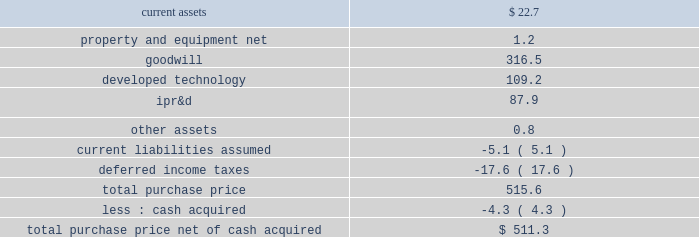Edwards lifesciences corporation notes to consolidated financial statements ( continued ) 7 .
Acquisitions ( continued ) transaction closed on january 23 , 2017 , and the consideration paid included the issuance of approximately 2.8 million shares of the company 2019s common stock ( fair value of $ 266.5 million ) and cash of $ 86.2 million .
The company recognized in 201ccontingent consideration liabilities 201d a $ 162.9 million liability for the estimated fair value of the contingent milestone payments .
The fair value of the contingent milestone payments will be remeasured each quarter , with changes in the fair value recognized within operating expenses on the consolidated statements of operations .
For further information on the fair value of the contingent milestone payments , see note 10 .
In connection with the acquisition , the company placed $ 27.6 million of the purchase price into escrow to satisfy any claims for indemnification made in accordance with the merger agreement .
Any funds remaining 15 months after the acquisition date will be disbursed to valtech 2019s former shareholders .
Acquisition-related costs of $ 0.6 million and $ 4.1 million were recorded in 201cselling , general , and administrative expenses 201d during the years ended december 31 , 2017 and 2016 , respectively .
Prior to the close of the transaction , valtech spun off its early- stage transseptal mitral valve replacement technology program .
Concurrent with the closing , the company entered into an agreement for an exclusive option to acquire that program and its associated intellectual property for approximately $ 200.0 million , subject to certain adjustments , plus an additional $ 50.0 million if a certain european regulatory approval is obtained within 10 years of the acquisition closing date .
The option expires two years after the closing date of the transaction , but can be extended by up to one year depending on the results of certain clinical trials .
Valtech is a developer of a transcatheter mitral and tricuspid valve repair system .
The company plans to add this technology to its portfolio of mitral and tricuspid repair products .
The acquisition was accounted for as a business combination .
Tangible and intangible assets acquired were recorded based on their estimated fair values at the acquisition date .
The excess of the purchase price over the fair value of net assets acquired was recorded to goodwill .
The table summarizes the fair values of the assets acquired and liabilities assumed ( in millions ) : .
Goodwill includes expected synergies and other benefits the company believes will result from the acquisition .
Goodwill was assigned to the company 2019s rest of world segment and is not deductible for tax purposes .
Ipr&d has been capitalized at fair value as an intangible asset with an indefinite life and will be assessed for impairment in subsequent periods .
The fair value of the ipr&d was determined using the income approach .
This approach determines fair value based on cash flow projections which are discounted to present value using a risk-adjusted rate of return .
The discount rates used to determine the fair value of the ipr&d ranged from 18.0% ( 18.0 % ) to 20.0% ( 20.0 % ) .
Completion of successful design developments , bench testing , pre-clinical studies .
What are current assets as a percentage of the total purchase price? 
Computations: (22.7 / 515.6)
Answer: 0.04403. 